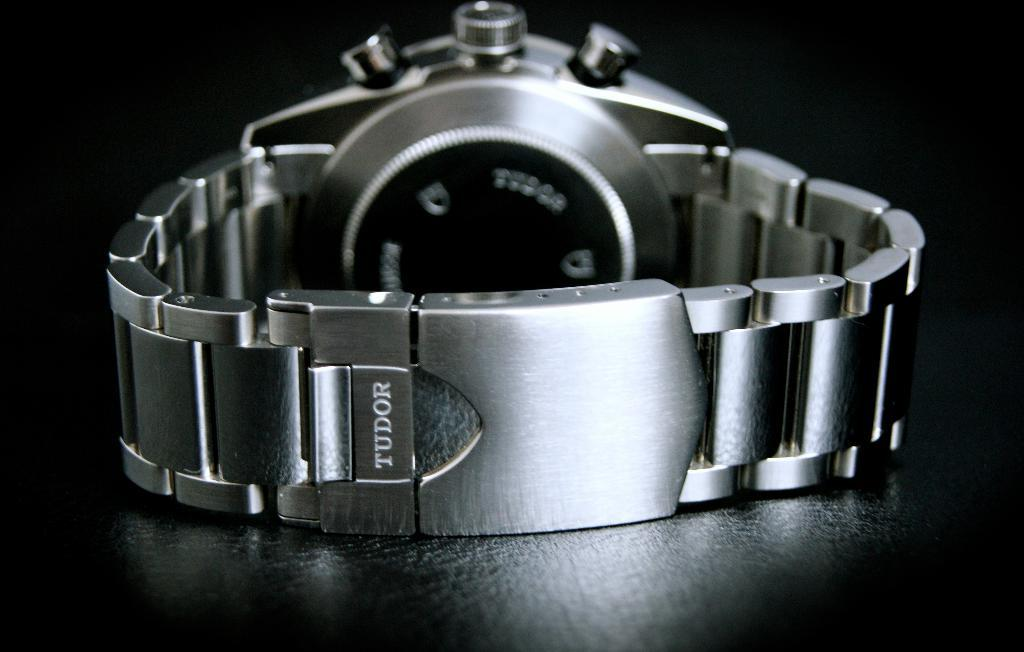<image>
Offer a succinct explanation of the picture presented. A silver watch with a black back and on the band it says Tudor. 